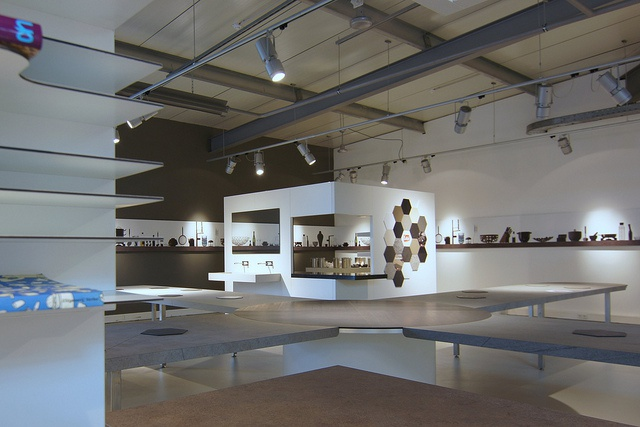Describe the objects in this image and their specific colors. I can see dining table in gray and black tones, dining table in gray, darkgray, and black tones, dining table in gray and darkgray tones, bench in gray, darkblue, and black tones, and book in gray and darkgray tones in this image. 